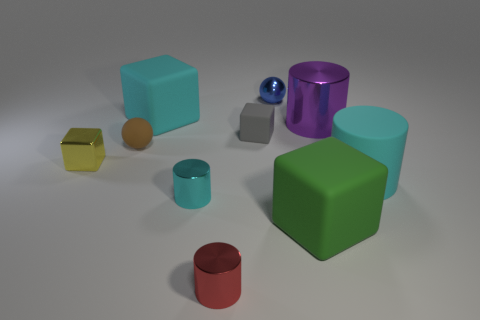Are there fewer cyan blocks that are left of the big green cube than brown balls to the left of the shiny block?
Your answer should be compact. No. There is a matte object that is left of the small gray matte block and behind the small brown rubber sphere; what is its shape?
Offer a terse response. Cube. How many big green matte things have the same shape as the small gray rubber thing?
Your answer should be very brief. 1. What is the size of the purple object that is made of the same material as the yellow thing?
Make the answer very short. Large. How many other purple metallic cylinders have the same size as the purple cylinder?
Offer a terse response. 0. What size is the metal thing that is the same color as the large rubber cylinder?
Make the answer very short. Small. There is a big matte thing that is behind the shiny cylinder behind the brown ball; what is its color?
Make the answer very short. Cyan. Are there any large cubes of the same color as the shiny sphere?
Offer a very short reply. No. The shiny cube that is the same size as the gray rubber cube is what color?
Provide a succinct answer. Yellow. Is the big cube to the left of the blue shiny ball made of the same material as the red object?
Give a very brief answer. No. 